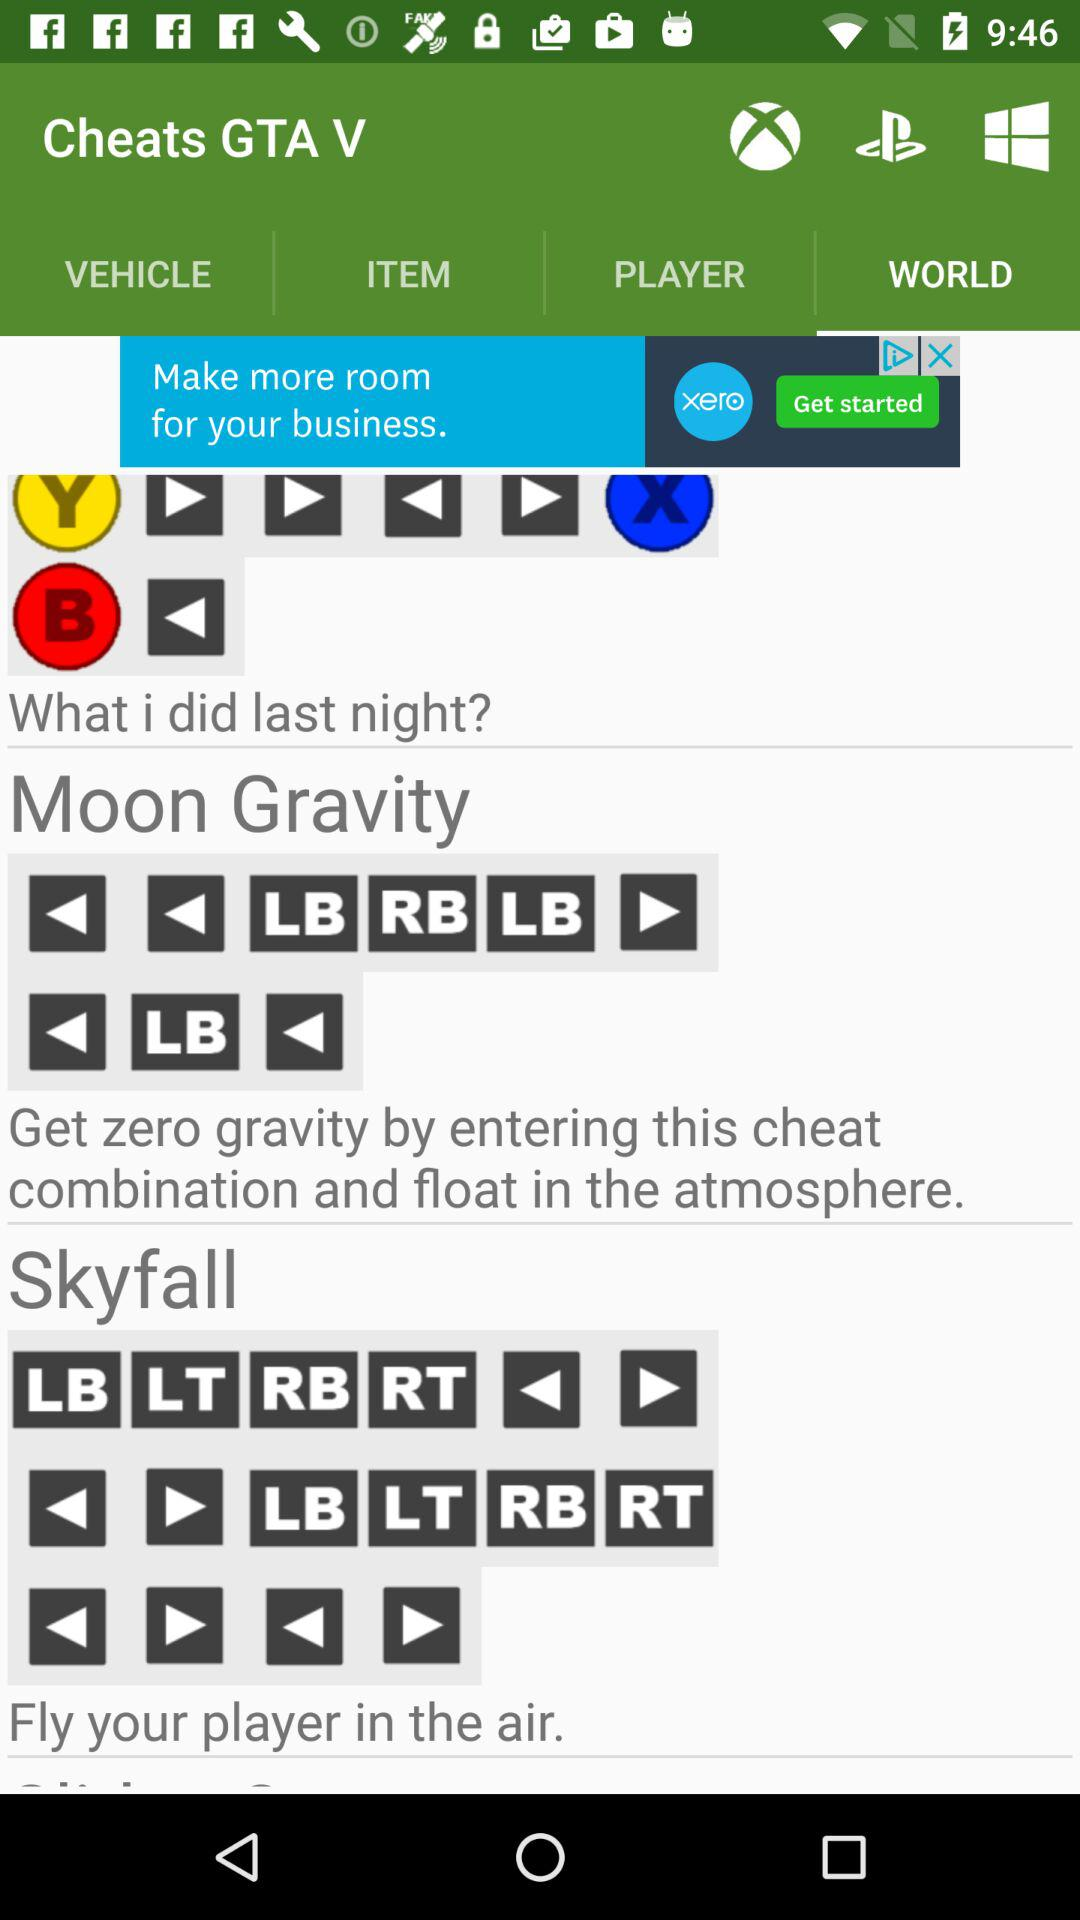What is the last night activity?
When the provided information is insufficient, respond with <no answer>. <no answer> 